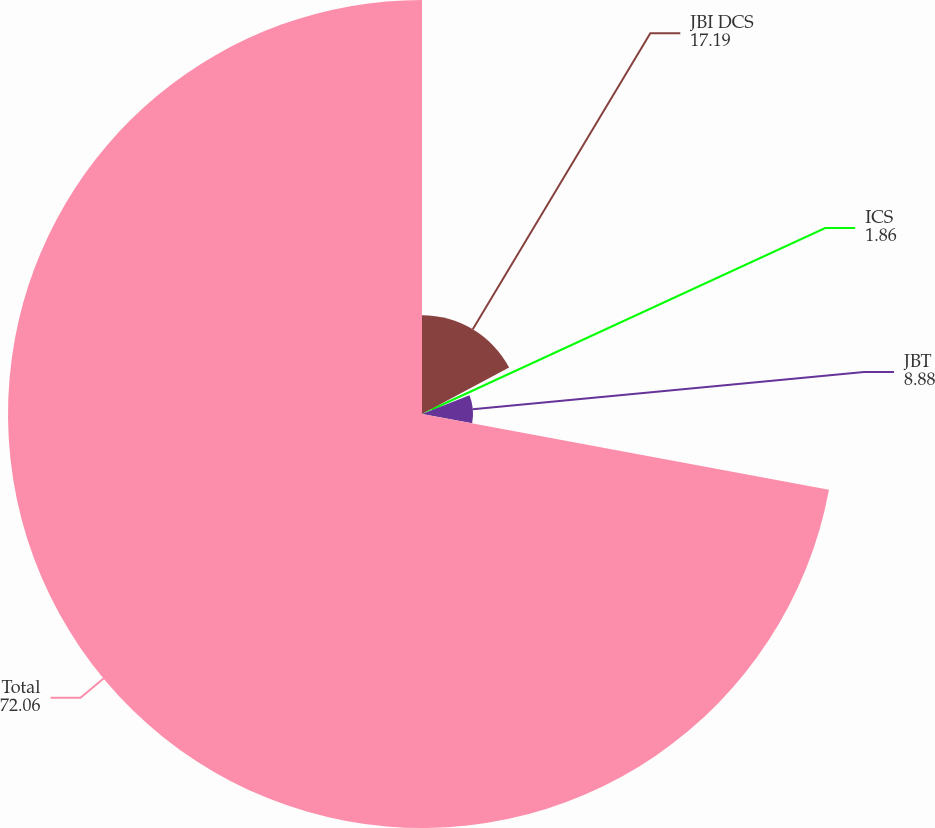<chart> <loc_0><loc_0><loc_500><loc_500><pie_chart><fcel>JBI DCS<fcel>ICS<fcel>JBT<fcel>Total<nl><fcel>17.19%<fcel>1.86%<fcel>8.88%<fcel>72.06%<nl></chart> 